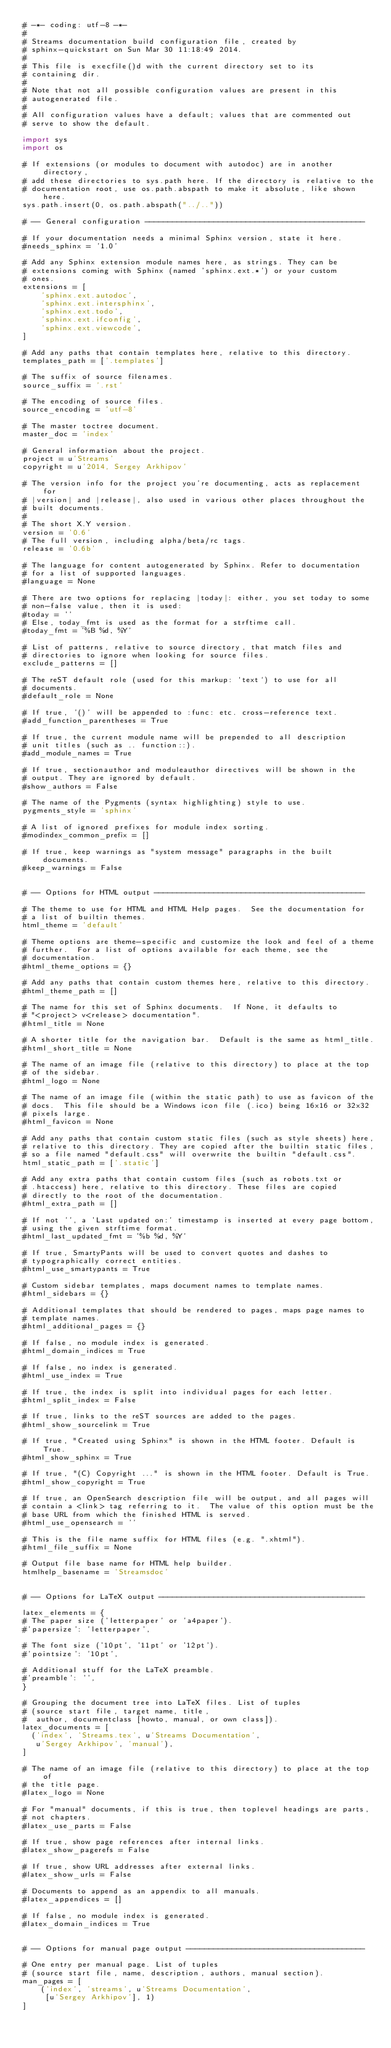<code> <loc_0><loc_0><loc_500><loc_500><_Python_># -*- coding: utf-8 -*-
#
# Streams documentation build configuration file, created by
# sphinx-quickstart on Sun Mar 30 11:18:49 2014.
#
# This file is execfile()d with the current directory set to its
# containing dir.
#
# Note that not all possible configuration values are present in this
# autogenerated file.
#
# All configuration values have a default; values that are commented out
# serve to show the default.

import sys
import os

# If extensions (or modules to document with autodoc) are in another directory,
# add these directories to sys.path here. If the directory is relative to the
# documentation root, use os.path.abspath to make it absolute, like shown here.
sys.path.insert(0, os.path.abspath("../.."))

# -- General configuration ------------------------------------------------

# If your documentation needs a minimal Sphinx version, state it here.
#needs_sphinx = '1.0'

# Add any Sphinx extension module names here, as strings. They can be
# extensions coming with Sphinx (named 'sphinx.ext.*') or your custom
# ones.
extensions = [
    'sphinx.ext.autodoc',
    'sphinx.ext.intersphinx',
    'sphinx.ext.todo',
    'sphinx.ext.ifconfig',
    'sphinx.ext.viewcode',
]

# Add any paths that contain templates here, relative to this directory.
templates_path = ['.templates']

# The suffix of source filenames.
source_suffix = '.rst'

# The encoding of source files.
source_encoding = 'utf-8'

# The master toctree document.
master_doc = 'index'

# General information about the project.
project = u'Streams'
copyright = u'2014, Sergey Arkhipov'

# The version info for the project you're documenting, acts as replacement for
# |version| and |release|, also used in various other places throughout the
# built documents.
#
# The short X.Y version.
version = '0.6'
# The full version, including alpha/beta/rc tags.
release = '0.6b'

# The language for content autogenerated by Sphinx. Refer to documentation
# for a list of supported languages.
#language = None

# There are two options for replacing |today|: either, you set today to some
# non-false value, then it is used:
#today = ''
# Else, today_fmt is used as the format for a strftime call.
#today_fmt = '%B %d, %Y'

# List of patterns, relative to source directory, that match files and
# directories to ignore when looking for source files.
exclude_patterns = []

# The reST default role (used for this markup: `text`) to use for all
# documents.
#default_role = None

# If true, '()' will be appended to :func: etc. cross-reference text.
#add_function_parentheses = True

# If true, the current module name will be prepended to all description
# unit titles (such as .. function::).
#add_module_names = True

# If true, sectionauthor and moduleauthor directives will be shown in the
# output. They are ignored by default.
#show_authors = False

# The name of the Pygments (syntax highlighting) style to use.
pygments_style = 'sphinx'

# A list of ignored prefixes for module index sorting.
#modindex_common_prefix = []

# If true, keep warnings as "system message" paragraphs in the built documents.
#keep_warnings = False


# -- Options for HTML output ----------------------------------------------

# The theme to use for HTML and HTML Help pages.  See the documentation for
# a list of builtin themes.
html_theme = 'default'

# Theme options are theme-specific and customize the look and feel of a theme
# further.  For a list of options available for each theme, see the
# documentation.
#html_theme_options = {}

# Add any paths that contain custom themes here, relative to this directory.
#html_theme_path = []

# The name for this set of Sphinx documents.  If None, it defaults to
# "<project> v<release> documentation".
#html_title = None

# A shorter title for the navigation bar.  Default is the same as html_title.
#html_short_title = None

# The name of an image file (relative to this directory) to place at the top
# of the sidebar.
#html_logo = None

# The name of an image file (within the static path) to use as favicon of the
# docs.  This file should be a Windows icon file (.ico) being 16x16 or 32x32
# pixels large.
#html_favicon = None

# Add any paths that contain custom static files (such as style sheets) here,
# relative to this directory. They are copied after the builtin static files,
# so a file named "default.css" will overwrite the builtin "default.css".
html_static_path = ['.static']

# Add any extra paths that contain custom files (such as robots.txt or
# .htaccess) here, relative to this directory. These files are copied
# directly to the root of the documentation.
#html_extra_path = []

# If not '', a 'Last updated on:' timestamp is inserted at every page bottom,
# using the given strftime format.
#html_last_updated_fmt = '%b %d, %Y'

# If true, SmartyPants will be used to convert quotes and dashes to
# typographically correct entities.
#html_use_smartypants = True

# Custom sidebar templates, maps document names to template names.
#html_sidebars = {}

# Additional templates that should be rendered to pages, maps page names to
# template names.
#html_additional_pages = {}

# If false, no module index is generated.
#html_domain_indices = True

# If false, no index is generated.
#html_use_index = True

# If true, the index is split into individual pages for each letter.
#html_split_index = False

# If true, links to the reST sources are added to the pages.
#html_show_sourcelink = True

# If true, "Created using Sphinx" is shown in the HTML footer. Default is True.
#html_show_sphinx = True

# If true, "(C) Copyright ..." is shown in the HTML footer. Default is True.
#html_show_copyright = True

# If true, an OpenSearch description file will be output, and all pages will
# contain a <link> tag referring to it.  The value of this option must be the
# base URL from which the finished HTML is served.
#html_use_opensearch = ''

# This is the file name suffix for HTML files (e.g. ".xhtml").
#html_file_suffix = None

# Output file base name for HTML help builder.
htmlhelp_basename = 'Streamsdoc'


# -- Options for LaTeX output ---------------------------------------------

latex_elements = {
# The paper size ('letterpaper' or 'a4paper').
#'papersize': 'letterpaper',

# The font size ('10pt', '11pt' or '12pt').
#'pointsize': '10pt',

# Additional stuff for the LaTeX preamble.
#'preamble': '',
}

# Grouping the document tree into LaTeX files. List of tuples
# (source start file, target name, title,
#  author, documentclass [howto, manual, or own class]).
latex_documents = [
  ('index', 'Streams.tex', u'Streams Documentation',
   u'Sergey Arkhipov', 'manual'),
]

# The name of an image file (relative to this directory) to place at the top of
# the title page.
#latex_logo = None

# For "manual" documents, if this is true, then toplevel headings are parts,
# not chapters.
#latex_use_parts = False

# If true, show page references after internal links.
#latex_show_pagerefs = False

# If true, show URL addresses after external links.
#latex_show_urls = False

# Documents to append as an appendix to all manuals.
#latex_appendices = []

# If false, no module index is generated.
#latex_domain_indices = True


# -- Options for manual page output ---------------------------------------

# One entry per manual page. List of tuples
# (source start file, name, description, authors, manual section).
man_pages = [
    ('index', 'streams', u'Streams Documentation',
     [u'Sergey Arkhipov'], 1)
]
</code> 